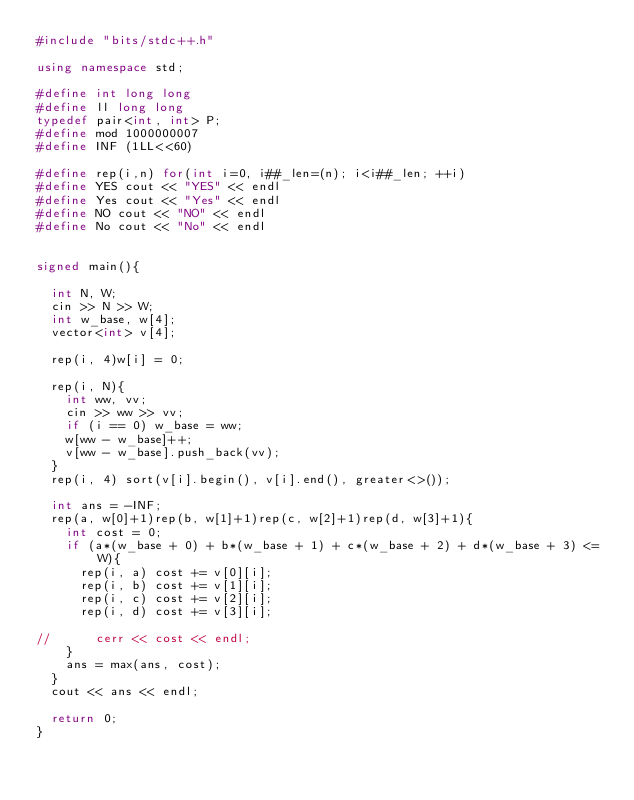<code> <loc_0><loc_0><loc_500><loc_500><_C++_>#include "bits/stdc++.h"

using namespace std;

#define int long long
#define ll long long
typedef pair<int, int> P;
#define mod 1000000007
#define INF (1LL<<60)

#define rep(i,n) for(int i=0, i##_len=(n); i<i##_len; ++i)
#define YES cout << "YES" << endl
#define Yes cout << "Yes" << endl
#define NO cout << "NO" << endl
#define No cout << "No" << endl


signed main(){

	int N, W;
	cin >> N >> W;
	int w_base, w[4];
	vector<int> v[4];

	rep(i, 4)w[i] = 0;

	rep(i, N){
		int ww, vv;
		cin >> ww >> vv;
		if (i == 0) w_base = ww;
		w[ww - w_base]++;
		v[ww - w_base].push_back(vv);
	}
	rep(i, 4) sort(v[i].begin(), v[i].end(), greater<>());

	int ans = -INF;
	rep(a, w[0]+1)rep(b, w[1]+1)rep(c, w[2]+1)rep(d, w[3]+1){
		int cost = 0;
		if (a*(w_base + 0) + b*(w_base + 1) + c*(w_base + 2) + d*(w_base + 3) <= W){
			rep(i, a) cost += v[0][i];
			rep(i, b) cost += v[1][i];
			rep(i, c) cost += v[2][i];
			rep(i, d) cost += v[3][i];

//			cerr << cost << endl;
		}
		ans = max(ans, cost);
	}
	cout << ans << endl;

	return 0;
}</code> 